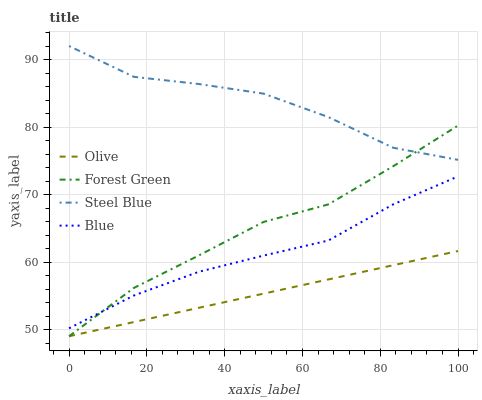Does Olive have the minimum area under the curve?
Answer yes or no. Yes. Does Steel Blue have the maximum area under the curve?
Answer yes or no. Yes. Does Blue have the minimum area under the curve?
Answer yes or no. No. Does Blue have the maximum area under the curve?
Answer yes or no. No. Is Olive the smoothest?
Answer yes or no. Yes. Is Steel Blue the roughest?
Answer yes or no. Yes. Is Blue the smoothest?
Answer yes or no. No. Is Blue the roughest?
Answer yes or no. No. Does Blue have the lowest value?
Answer yes or no. No. Does Blue have the highest value?
Answer yes or no. No. Is Olive less than Steel Blue?
Answer yes or no. Yes. Is Steel Blue greater than Blue?
Answer yes or no. Yes. Does Olive intersect Steel Blue?
Answer yes or no. No. 